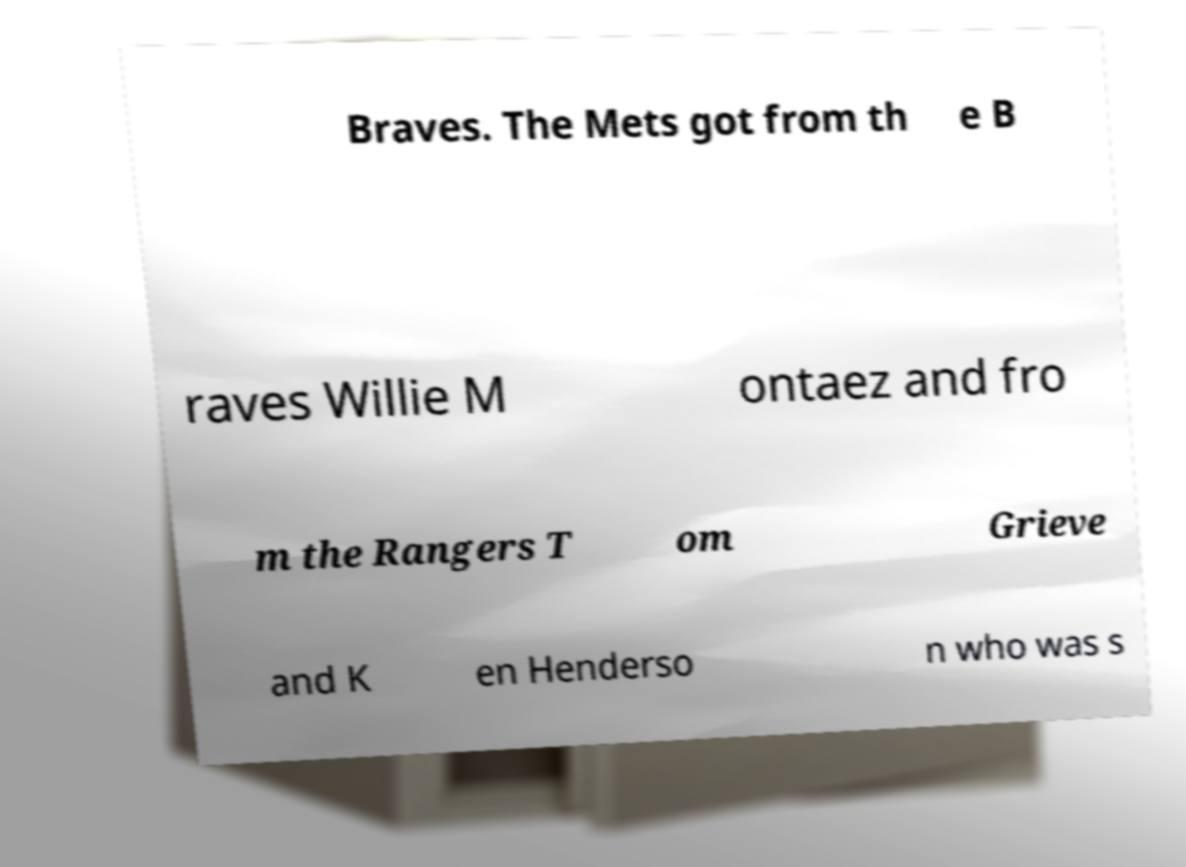I need the written content from this picture converted into text. Can you do that? Braves. The Mets got from th e B raves Willie M ontaez and fro m the Rangers T om Grieve and K en Henderso n who was s 